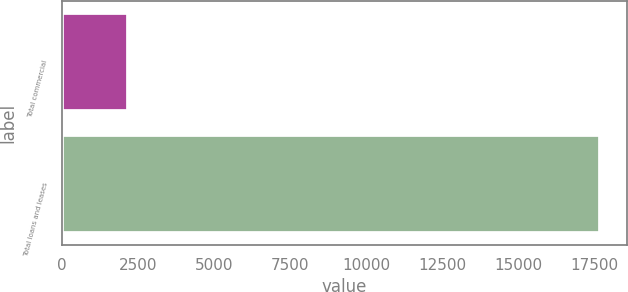Convert chart to OTSL. <chart><loc_0><loc_0><loc_500><loc_500><bar_chart><fcel>Total commercial<fcel>Total loans and leases<nl><fcel>2172<fcel>17685<nl></chart> 